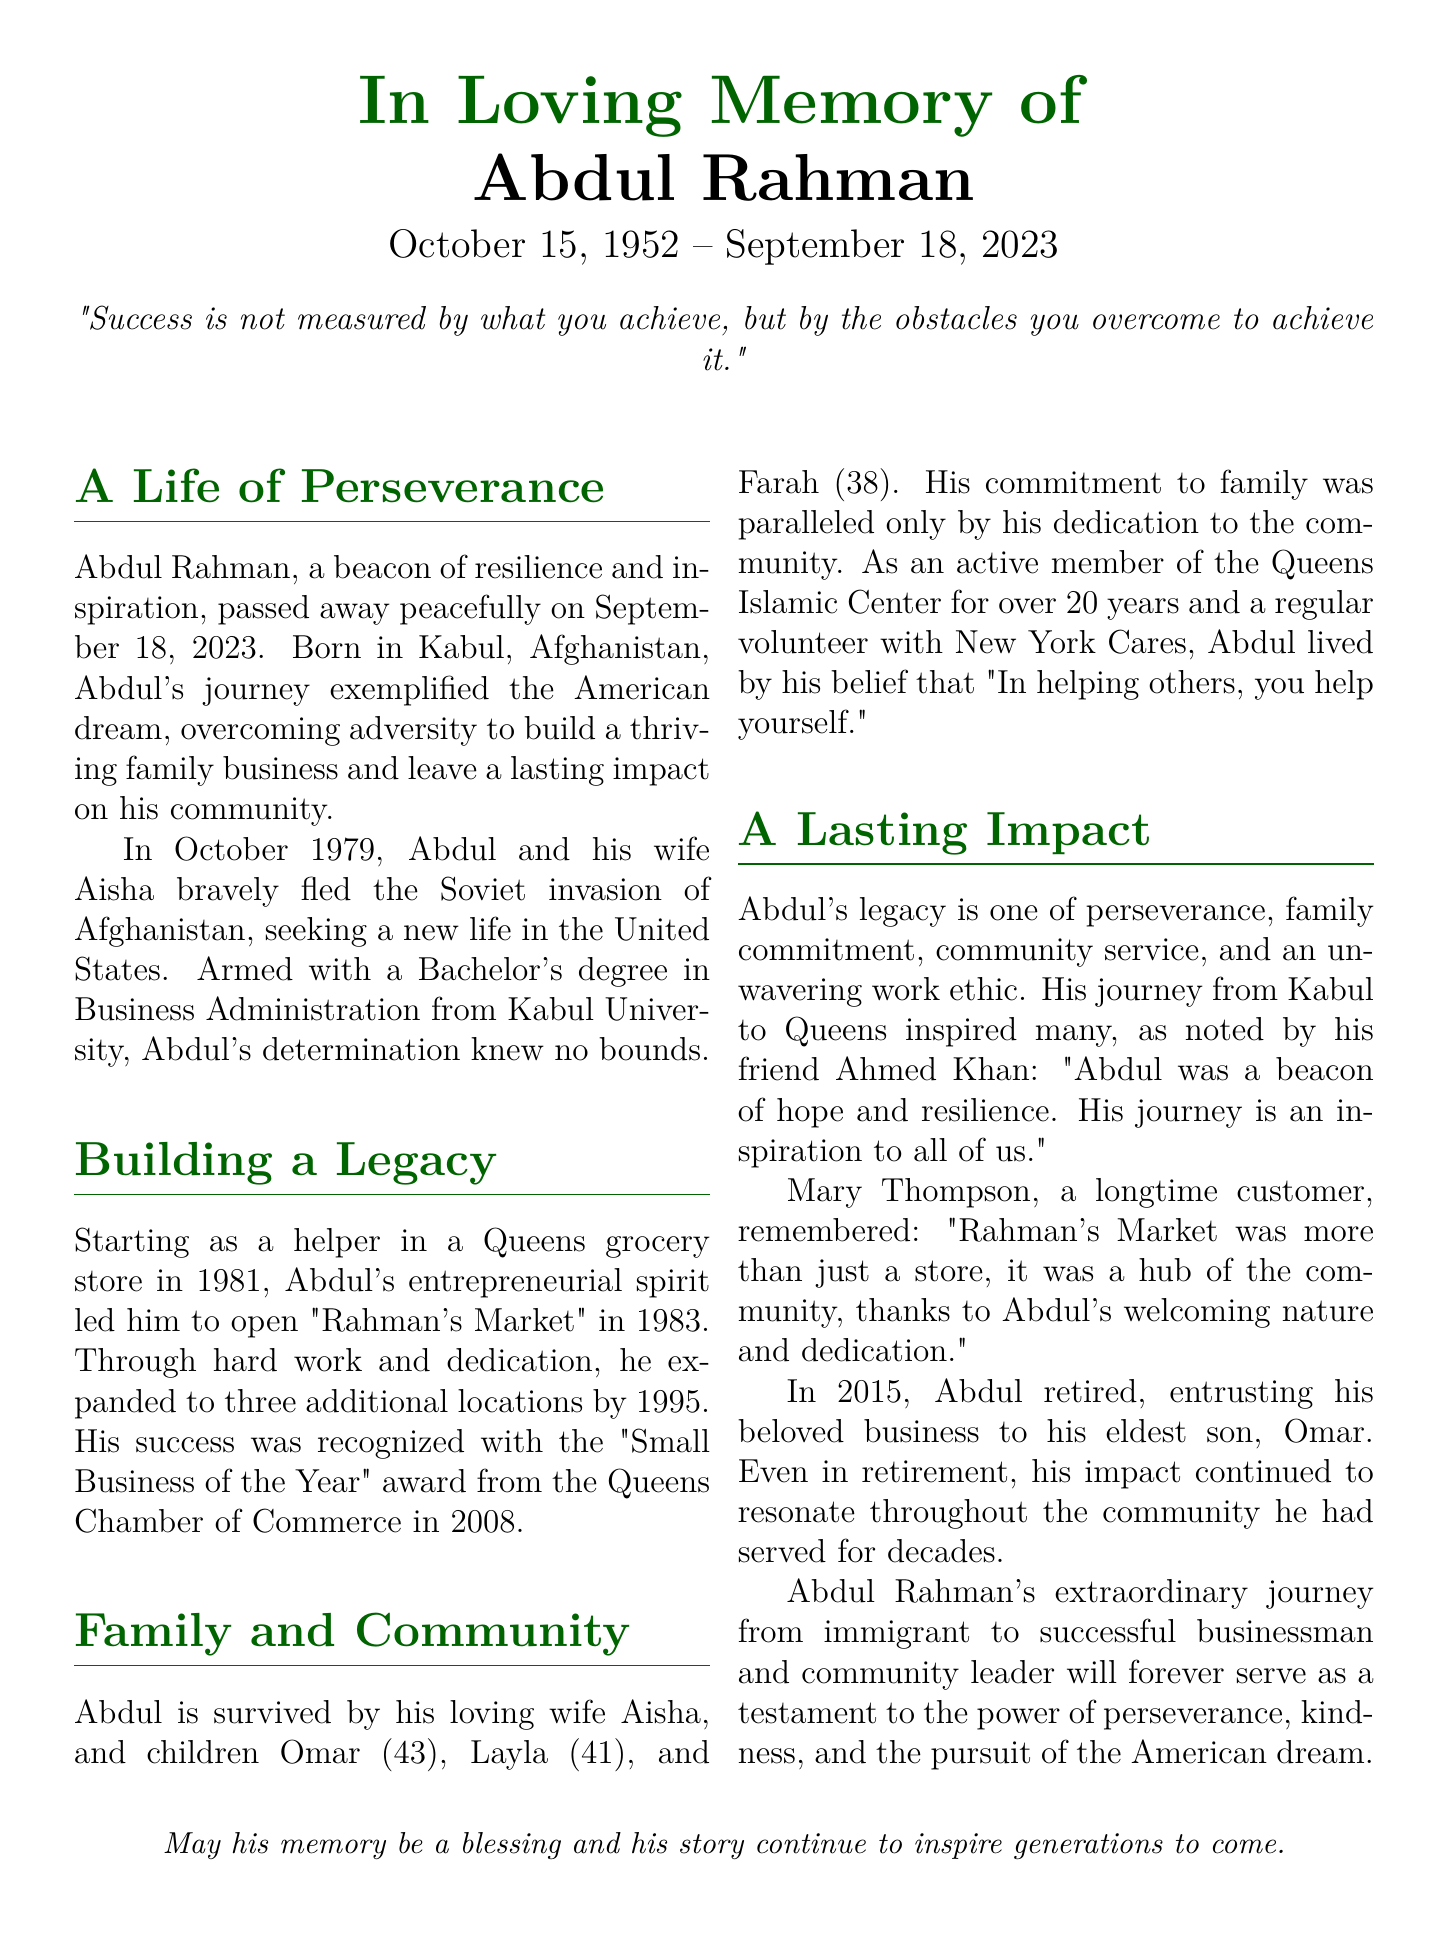what was Abdul Rahman's birth date? The document states Abdul Rahman's birth date as October 15, 1952.
Answer: October 15, 1952 what was the name of Abdul Rahman's market? The document mentions that Abdul opened "Rahman's Market."
Answer: Rahman's Market how many years did Abdul's family business operate before he retired? Abdul opened his market in 1983 and retired in 2015, which spans 32 years.
Answer: 32 who is Abdul Rahman's eldest son? The document states that his eldest son is Omar.
Answer: Omar what award did Rahman's Market receive, and in what year? The document indicates that the market received the "Small Business of the Year" award in 2008.
Answer: Small Business of the Year, 2008 what was Abdul's commitment towards his community? Abdul's commitment to the community is noted by his active membership in the Queens Islamic Center and volunteering with New York Cares.
Answer: Community service how did Abdul view helping others? Abdul believed that "In helping others, you help yourself."
Answer: Helping others what does the phrase "In Loving Memory of" signify in the document? This phrase indicates that the document is an obituary honoring the life and legacy of Abdul Rahman.
Answer: Obituary who described Abdul as "a beacon of hope and resilience"? The document states that this was said by his friend Ahmed Khan.
Answer: Ahmed Khan 